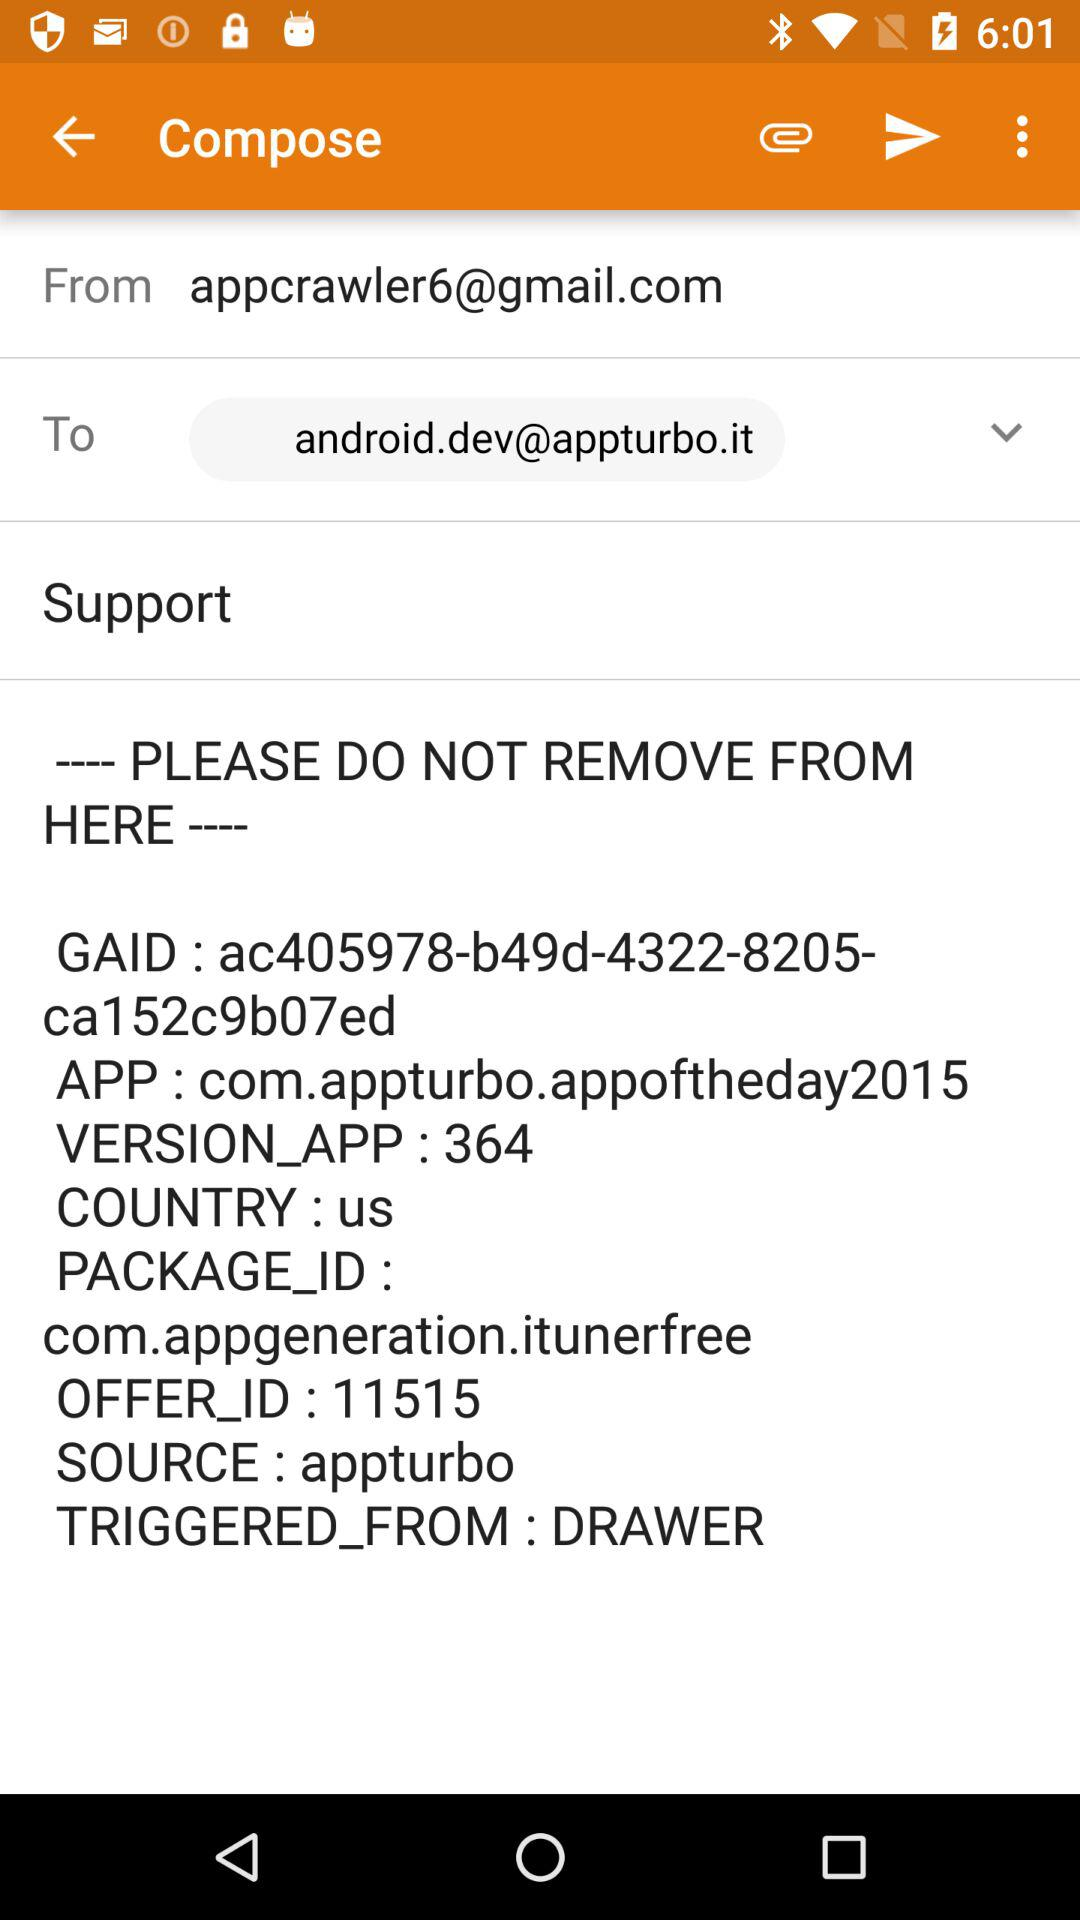When was this email sent?
When the provided information is insufficient, respond with <no answer>. <no answer> 